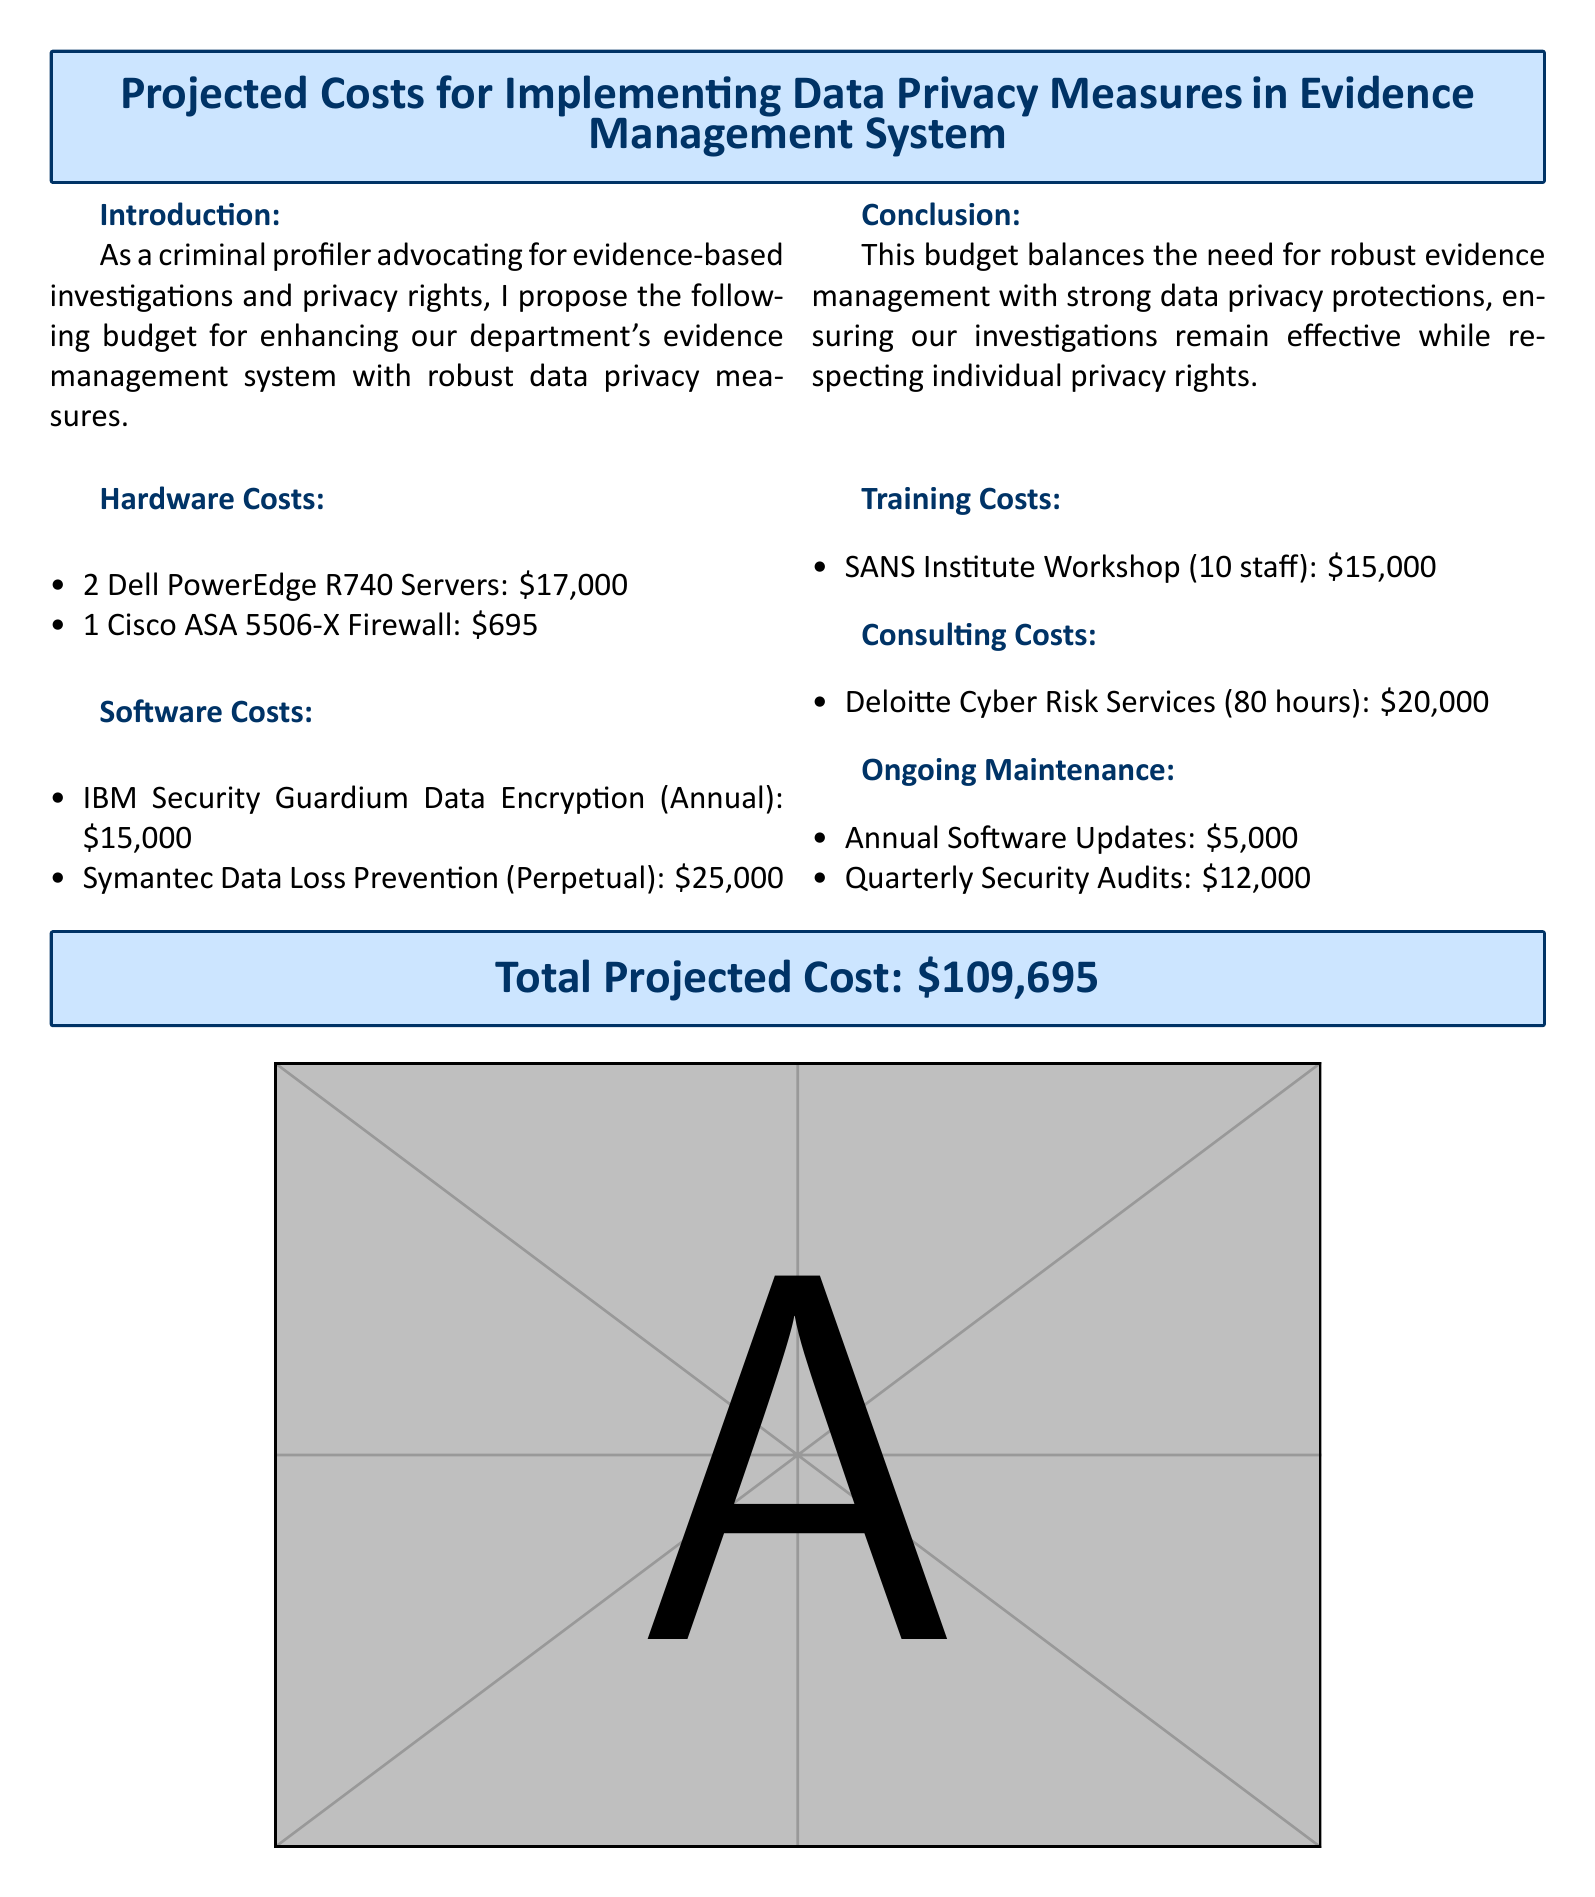what is the total projected cost? The total projected cost is stated clearly at the end of the document.
Answer: $109,695 how many Dell PowerEdge R740 Servers are included? The document lists the number of servers in the hardware costs section.
Answer: 2 what is the cost of the Symantec Data Loss Prevention? The document specifies the cost for the software in the software costs section.
Answer: $25,000 who provides the consulting services? The name of the consulting service provider is mentioned in the consulting costs section.
Answer: Deloitte how much is allocated for quarterly security audits? The amount for quarterly security audits is listed under ongoing maintenance in the document.
Answer: $12,000 what is the total cost for training? The document includes the training costs in a dedicated section.
Answer: $15,000 how many hours of consulting are included? The document specifies the total hours allocated for consulting services.
Answer: 80 hours what is the cost of the IBM Security Guardium Data Encryption? The document provides the annual cost for the software in the software costs section.
Answer: $15,000 what is the hardware cost total? This requires adding the individual costs of the hardware items listed.
Answer: $17,695 